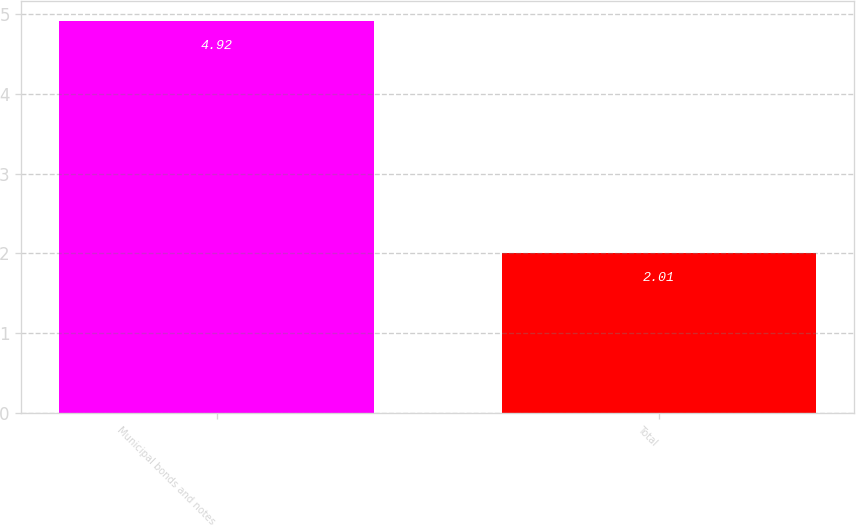<chart> <loc_0><loc_0><loc_500><loc_500><bar_chart><fcel>Municipal bonds and notes<fcel>Total<nl><fcel>4.92<fcel>2.01<nl></chart> 